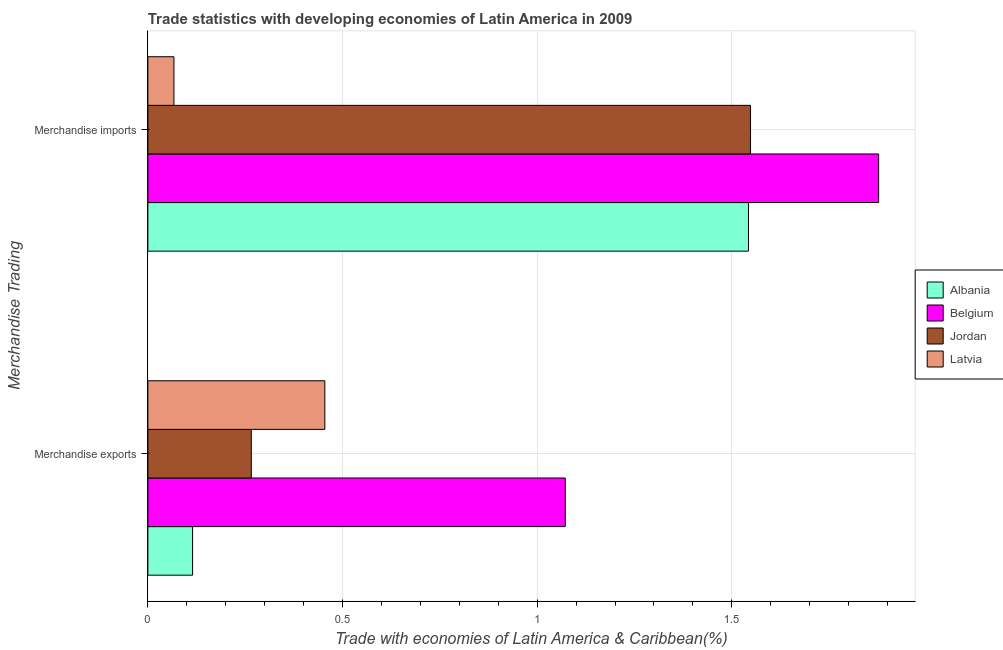How many different coloured bars are there?
Offer a terse response. 4. Are the number of bars on each tick of the Y-axis equal?
Keep it short and to the point. Yes. How many bars are there on the 1st tick from the top?
Offer a very short reply. 4. How many bars are there on the 2nd tick from the bottom?
Give a very brief answer. 4. What is the label of the 1st group of bars from the top?
Your response must be concise. Merchandise imports. What is the merchandise exports in Belgium?
Ensure brevity in your answer.  1.07. Across all countries, what is the maximum merchandise exports?
Provide a short and direct response. 1.07. Across all countries, what is the minimum merchandise exports?
Give a very brief answer. 0.11. In which country was the merchandise imports minimum?
Give a very brief answer. Latvia. What is the total merchandise imports in the graph?
Offer a terse response. 5.04. What is the difference between the merchandise exports in Albania and that in Latvia?
Your answer should be compact. -0.34. What is the difference between the merchandise exports in Jordan and the merchandise imports in Latvia?
Provide a succinct answer. 0.2. What is the average merchandise imports per country?
Offer a terse response. 1.26. What is the difference between the merchandise exports and merchandise imports in Latvia?
Provide a short and direct response. 0.39. What is the ratio of the merchandise exports in Latvia to that in Albania?
Offer a terse response. 3.96. Is the merchandise imports in Jordan less than that in Belgium?
Make the answer very short. Yes. What does the 4th bar from the top in Merchandise exports represents?
Offer a very short reply. Albania. What does the 1st bar from the bottom in Merchandise exports represents?
Ensure brevity in your answer.  Albania. How many bars are there?
Your response must be concise. 8. Are all the bars in the graph horizontal?
Make the answer very short. Yes. How many countries are there in the graph?
Offer a very short reply. 4. What is the difference between two consecutive major ticks on the X-axis?
Make the answer very short. 0.5. Are the values on the major ticks of X-axis written in scientific E-notation?
Provide a succinct answer. No. Does the graph contain grids?
Your response must be concise. Yes. Where does the legend appear in the graph?
Your answer should be compact. Center right. What is the title of the graph?
Offer a very short reply. Trade statistics with developing economies of Latin America in 2009. Does "France" appear as one of the legend labels in the graph?
Keep it short and to the point. No. What is the label or title of the X-axis?
Provide a short and direct response. Trade with economies of Latin America & Caribbean(%). What is the label or title of the Y-axis?
Provide a succinct answer. Merchandise Trading. What is the Trade with economies of Latin America & Caribbean(%) of Albania in Merchandise exports?
Offer a very short reply. 0.11. What is the Trade with economies of Latin America & Caribbean(%) of Belgium in Merchandise exports?
Give a very brief answer. 1.07. What is the Trade with economies of Latin America & Caribbean(%) of Jordan in Merchandise exports?
Your response must be concise. 0.27. What is the Trade with economies of Latin America & Caribbean(%) of Latvia in Merchandise exports?
Your answer should be compact. 0.45. What is the Trade with economies of Latin America & Caribbean(%) of Albania in Merchandise imports?
Offer a terse response. 1.54. What is the Trade with economies of Latin America & Caribbean(%) in Belgium in Merchandise imports?
Make the answer very short. 1.88. What is the Trade with economies of Latin America & Caribbean(%) in Jordan in Merchandise imports?
Your answer should be compact. 1.55. What is the Trade with economies of Latin America & Caribbean(%) in Latvia in Merchandise imports?
Provide a short and direct response. 0.07. Across all Merchandise Trading, what is the maximum Trade with economies of Latin America & Caribbean(%) in Albania?
Your answer should be very brief. 1.54. Across all Merchandise Trading, what is the maximum Trade with economies of Latin America & Caribbean(%) of Belgium?
Keep it short and to the point. 1.88. Across all Merchandise Trading, what is the maximum Trade with economies of Latin America & Caribbean(%) of Jordan?
Ensure brevity in your answer.  1.55. Across all Merchandise Trading, what is the maximum Trade with economies of Latin America & Caribbean(%) in Latvia?
Offer a very short reply. 0.45. Across all Merchandise Trading, what is the minimum Trade with economies of Latin America & Caribbean(%) of Albania?
Provide a succinct answer. 0.11. Across all Merchandise Trading, what is the minimum Trade with economies of Latin America & Caribbean(%) in Belgium?
Ensure brevity in your answer.  1.07. Across all Merchandise Trading, what is the minimum Trade with economies of Latin America & Caribbean(%) of Jordan?
Provide a succinct answer. 0.27. Across all Merchandise Trading, what is the minimum Trade with economies of Latin America & Caribbean(%) in Latvia?
Your response must be concise. 0.07. What is the total Trade with economies of Latin America & Caribbean(%) of Albania in the graph?
Provide a succinct answer. 1.66. What is the total Trade with economies of Latin America & Caribbean(%) of Belgium in the graph?
Your response must be concise. 2.95. What is the total Trade with economies of Latin America & Caribbean(%) in Jordan in the graph?
Keep it short and to the point. 1.81. What is the total Trade with economies of Latin America & Caribbean(%) in Latvia in the graph?
Provide a short and direct response. 0.52. What is the difference between the Trade with economies of Latin America & Caribbean(%) of Albania in Merchandise exports and that in Merchandise imports?
Make the answer very short. -1.43. What is the difference between the Trade with economies of Latin America & Caribbean(%) in Belgium in Merchandise exports and that in Merchandise imports?
Your response must be concise. -0.81. What is the difference between the Trade with economies of Latin America & Caribbean(%) of Jordan in Merchandise exports and that in Merchandise imports?
Your response must be concise. -1.28. What is the difference between the Trade with economies of Latin America & Caribbean(%) in Latvia in Merchandise exports and that in Merchandise imports?
Offer a very short reply. 0.39. What is the difference between the Trade with economies of Latin America & Caribbean(%) of Albania in Merchandise exports and the Trade with economies of Latin America & Caribbean(%) of Belgium in Merchandise imports?
Keep it short and to the point. -1.76. What is the difference between the Trade with economies of Latin America & Caribbean(%) of Albania in Merchandise exports and the Trade with economies of Latin America & Caribbean(%) of Jordan in Merchandise imports?
Give a very brief answer. -1.43. What is the difference between the Trade with economies of Latin America & Caribbean(%) in Albania in Merchandise exports and the Trade with economies of Latin America & Caribbean(%) in Latvia in Merchandise imports?
Make the answer very short. 0.05. What is the difference between the Trade with economies of Latin America & Caribbean(%) of Belgium in Merchandise exports and the Trade with economies of Latin America & Caribbean(%) of Jordan in Merchandise imports?
Provide a short and direct response. -0.48. What is the difference between the Trade with economies of Latin America & Caribbean(%) of Belgium in Merchandise exports and the Trade with economies of Latin America & Caribbean(%) of Latvia in Merchandise imports?
Offer a very short reply. 1.01. What is the difference between the Trade with economies of Latin America & Caribbean(%) of Jordan in Merchandise exports and the Trade with economies of Latin America & Caribbean(%) of Latvia in Merchandise imports?
Keep it short and to the point. 0.2. What is the average Trade with economies of Latin America & Caribbean(%) in Albania per Merchandise Trading?
Provide a succinct answer. 0.83. What is the average Trade with economies of Latin America & Caribbean(%) in Belgium per Merchandise Trading?
Give a very brief answer. 1.47. What is the average Trade with economies of Latin America & Caribbean(%) of Jordan per Merchandise Trading?
Offer a very short reply. 0.91. What is the average Trade with economies of Latin America & Caribbean(%) in Latvia per Merchandise Trading?
Give a very brief answer. 0.26. What is the difference between the Trade with economies of Latin America & Caribbean(%) of Albania and Trade with economies of Latin America & Caribbean(%) of Belgium in Merchandise exports?
Offer a terse response. -0.96. What is the difference between the Trade with economies of Latin America & Caribbean(%) in Albania and Trade with economies of Latin America & Caribbean(%) in Jordan in Merchandise exports?
Give a very brief answer. -0.15. What is the difference between the Trade with economies of Latin America & Caribbean(%) of Albania and Trade with economies of Latin America & Caribbean(%) of Latvia in Merchandise exports?
Provide a short and direct response. -0.34. What is the difference between the Trade with economies of Latin America & Caribbean(%) in Belgium and Trade with economies of Latin America & Caribbean(%) in Jordan in Merchandise exports?
Your answer should be very brief. 0.81. What is the difference between the Trade with economies of Latin America & Caribbean(%) of Belgium and Trade with economies of Latin America & Caribbean(%) of Latvia in Merchandise exports?
Your answer should be compact. 0.62. What is the difference between the Trade with economies of Latin America & Caribbean(%) in Jordan and Trade with economies of Latin America & Caribbean(%) in Latvia in Merchandise exports?
Ensure brevity in your answer.  -0.19. What is the difference between the Trade with economies of Latin America & Caribbean(%) in Albania and Trade with economies of Latin America & Caribbean(%) in Belgium in Merchandise imports?
Make the answer very short. -0.33. What is the difference between the Trade with economies of Latin America & Caribbean(%) in Albania and Trade with economies of Latin America & Caribbean(%) in Jordan in Merchandise imports?
Make the answer very short. -0.01. What is the difference between the Trade with economies of Latin America & Caribbean(%) of Albania and Trade with economies of Latin America & Caribbean(%) of Latvia in Merchandise imports?
Give a very brief answer. 1.48. What is the difference between the Trade with economies of Latin America & Caribbean(%) in Belgium and Trade with economies of Latin America & Caribbean(%) in Jordan in Merchandise imports?
Ensure brevity in your answer.  0.33. What is the difference between the Trade with economies of Latin America & Caribbean(%) of Belgium and Trade with economies of Latin America & Caribbean(%) of Latvia in Merchandise imports?
Your response must be concise. 1.81. What is the difference between the Trade with economies of Latin America & Caribbean(%) of Jordan and Trade with economies of Latin America & Caribbean(%) of Latvia in Merchandise imports?
Provide a short and direct response. 1.48. What is the ratio of the Trade with economies of Latin America & Caribbean(%) in Albania in Merchandise exports to that in Merchandise imports?
Ensure brevity in your answer.  0.07. What is the ratio of the Trade with economies of Latin America & Caribbean(%) of Belgium in Merchandise exports to that in Merchandise imports?
Your response must be concise. 0.57. What is the ratio of the Trade with economies of Latin America & Caribbean(%) in Jordan in Merchandise exports to that in Merchandise imports?
Ensure brevity in your answer.  0.17. What is the ratio of the Trade with economies of Latin America & Caribbean(%) of Latvia in Merchandise exports to that in Merchandise imports?
Keep it short and to the point. 6.79. What is the difference between the highest and the second highest Trade with economies of Latin America & Caribbean(%) in Albania?
Provide a short and direct response. 1.43. What is the difference between the highest and the second highest Trade with economies of Latin America & Caribbean(%) of Belgium?
Offer a very short reply. 0.81. What is the difference between the highest and the second highest Trade with economies of Latin America & Caribbean(%) in Jordan?
Ensure brevity in your answer.  1.28. What is the difference between the highest and the second highest Trade with economies of Latin America & Caribbean(%) of Latvia?
Keep it short and to the point. 0.39. What is the difference between the highest and the lowest Trade with economies of Latin America & Caribbean(%) of Albania?
Your answer should be very brief. 1.43. What is the difference between the highest and the lowest Trade with economies of Latin America & Caribbean(%) in Belgium?
Offer a very short reply. 0.81. What is the difference between the highest and the lowest Trade with economies of Latin America & Caribbean(%) of Jordan?
Your answer should be very brief. 1.28. What is the difference between the highest and the lowest Trade with economies of Latin America & Caribbean(%) of Latvia?
Provide a short and direct response. 0.39. 